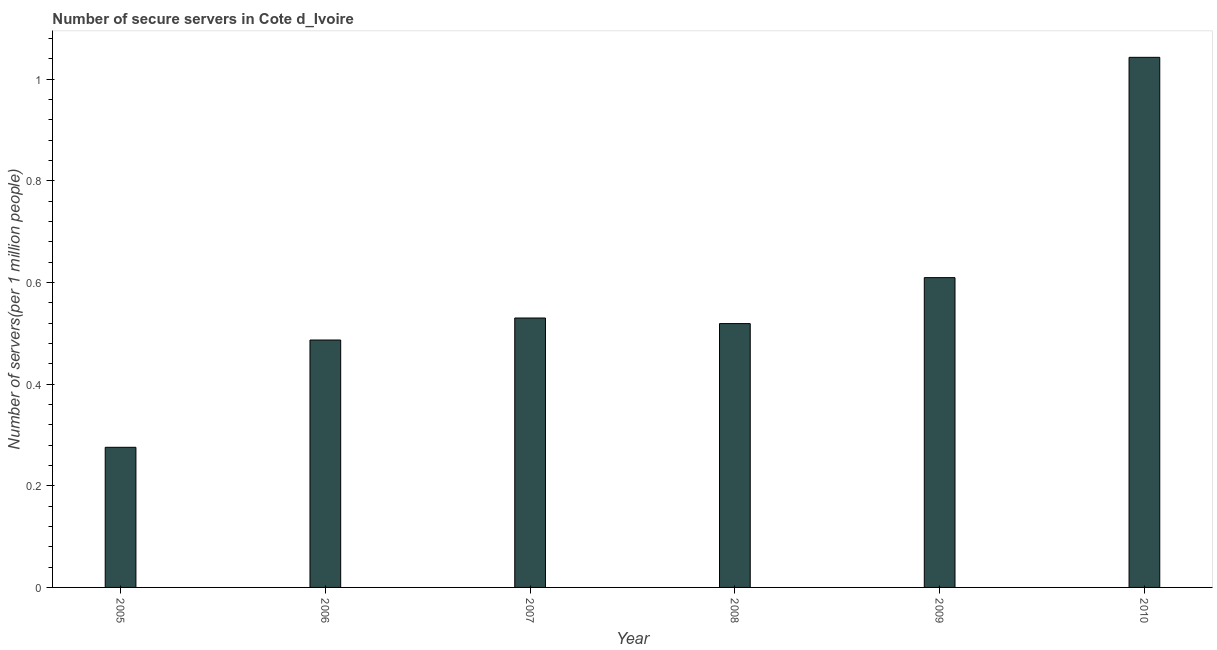Does the graph contain any zero values?
Ensure brevity in your answer.  No. Does the graph contain grids?
Your answer should be compact. No. What is the title of the graph?
Your answer should be very brief. Number of secure servers in Cote d_Ivoire. What is the label or title of the X-axis?
Your answer should be very brief. Year. What is the label or title of the Y-axis?
Give a very brief answer. Number of servers(per 1 million people). What is the number of secure internet servers in 2009?
Your response must be concise. 0.61. Across all years, what is the maximum number of secure internet servers?
Your answer should be compact. 1.04. Across all years, what is the minimum number of secure internet servers?
Provide a short and direct response. 0.28. In which year was the number of secure internet servers maximum?
Ensure brevity in your answer.  2010. In which year was the number of secure internet servers minimum?
Make the answer very short. 2005. What is the sum of the number of secure internet servers?
Give a very brief answer. 3.46. What is the difference between the number of secure internet servers in 2006 and 2009?
Your answer should be very brief. -0.12. What is the average number of secure internet servers per year?
Your response must be concise. 0.58. What is the median number of secure internet servers?
Provide a short and direct response. 0.52. Do a majority of the years between 2009 and 2005 (inclusive) have number of secure internet servers greater than 0.32 ?
Offer a very short reply. Yes. What is the ratio of the number of secure internet servers in 2005 to that in 2007?
Offer a very short reply. 0.52. Is the number of secure internet servers in 2006 less than that in 2010?
Provide a short and direct response. Yes. Is the difference between the number of secure internet servers in 2009 and 2010 greater than the difference between any two years?
Offer a terse response. No. What is the difference between the highest and the second highest number of secure internet servers?
Ensure brevity in your answer.  0.43. Is the sum of the number of secure internet servers in 2008 and 2009 greater than the maximum number of secure internet servers across all years?
Ensure brevity in your answer.  Yes. What is the difference between the highest and the lowest number of secure internet servers?
Offer a terse response. 0.77. In how many years, is the number of secure internet servers greater than the average number of secure internet servers taken over all years?
Keep it short and to the point. 2. How many bars are there?
Offer a terse response. 6. How many years are there in the graph?
Your answer should be very brief. 6. What is the Number of servers(per 1 million people) of 2005?
Make the answer very short. 0.28. What is the Number of servers(per 1 million people) of 2006?
Offer a very short reply. 0.49. What is the Number of servers(per 1 million people) of 2007?
Ensure brevity in your answer.  0.53. What is the Number of servers(per 1 million people) of 2008?
Keep it short and to the point. 0.52. What is the Number of servers(per 1 million people) of 2009?
Keep it short and to the point. 0.61. What is the Number of servers(per 1 million people) in 2010?
Give a very brief answer. 1.04. What is the difference between the Number of servers(per 1 million people) in 2005 and 2006?
Offer a very short reply. -0.21. What is the difference between the Number of servers(per 1 million people) in 2005 and 2007?
Offer a very short reply. -0.25. What is the difference between the Number of servers(per 1 million people) in 2005 and 2008?
Offer a very short reply. -0.24. What is the difference between the Number of servers(per 1 million people) in 2005 and 2009?
Offer a terse response. -0.33. What is the difference between the Number of servers(per 1 million people) in 2005 and 2010?
Provide a short and direct response. -0.77. What is the difference between the Number of servers(per 1 million people) in 2006 and 2007?
Offer a very short reply. -0.04. What is the difference between the Number of servers(per 1 million people) in 2006 and 2008?
Your answer should be very brief. -0.03. What is the difference between the Number of servers(per 1 million people) in 2006 and 2009?
Offer a very short reply. -0.12. What is the difference between the Number of servers(per 1 million people) in 2006 and 2010?
Ensure brevity in your answer.  -0.56. What is the difference between the Number of servers(per 1 million people) in 2007 and 2008?
Provide a short and direct response. 0.01. What is the difference between the Number of servers(per 1 million people) in 2007 and 2009?
Your answer should be very brief. -0.08. What is the difference between the Number of servers(per 1 million people) in 2007 and 2010?
Keep it short and to the point. -0.51. What is the difference between the Number of servers(per 1 million people) in 2008 and 2009?
Ensure brevity in your answer.  -0.09. What is the difference between the Number of servers(per 1 million people) in 2008 and 2010?
Your response must be concise. -0.52. What is the difference between the Number of servers(per 1 million people) in 2009 and 2010?
Provide a short and direct response. -0.43. What is the ratio of the Number of servers(per 1 million people) in 2005 to that in 2006?
Provide a succinct answer. 0.57. What is the ratio of the Number of servers(per 1 million people) in 2005 to that in 2007?
Offer a terse response. 0.52. What is the ratio of the Number of servers(per 1 million people) in 2005 to that in 2008?
Offer a terse response. 0.53. What is the ratio of the Number of servers(per 1 million people) in 2005 to that in 2009?
Make the answer very short. 0.45. What is the ratio of the Number of servers(per 1 million people) in 2005 to that in 2010?
Give a very brief answer. 0.26. What is the ratio of the Number of servers(per 1 million people) in 2006 to that in 2007?
Provide a succinct answer. 0.92. What is the ratio of the Number of servers(per 1 million people) in 2006 to that in 2008?
Your answer should be very brief. 0.94. What is the ratio of the Number of servers(per 1 million people) in 2006 to that in 2009?
Make the answer very short. 0.8. What is the ratio of the Number of servers(per 1 million people) in 2006 to that in 2010?
Your answer should be very brief. 0.47. What is the ratio of the Number of servers(per 1 million people) in 2007 to that in 2008?
Offer a very short reply. 1.02. What is the ratio of the Number of servers(per 1 million people) in 2007 to that in 2009?
Offer a very short reply. 0.87. What is the ratio of the Number of servers(per 1 million people) in 2007 to that in 2010?
Offer a terse response. 0.51. What is the ratio of the Number of servers(per 1 million people) in 2008 to that in 2009?
Offer a terse response. 0.85. What is the ratio of the Number of servers(per 1 million people) in 2008 to that in 2010?
Offer a terse response. 0.5. What is the ratio of the Number of servers(per 1 million people) in 2009 to that in 2010?
Ensure brevity in your answer.  0.58. 